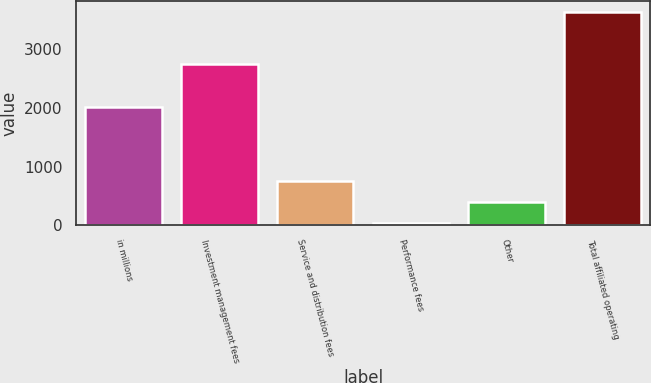Convert chart. <chart><loc_0><loc_0><loc_500><loc_500><bar_chart><fcel>in millions<fcel>Investment management fees<fcel>Service and distribution fees<fcel>Performance fees<fcel>Other<fcel>Total affiliated operating<nl><fcel>2012<fcel>2754.2<fcel>754.16<fcel>32.6<fcel>393.38<fcel>3640.4<nl></chart> 